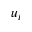<formula> <loc_0><loc_0><loc_500><loc_500>u _ { i }</formula> 